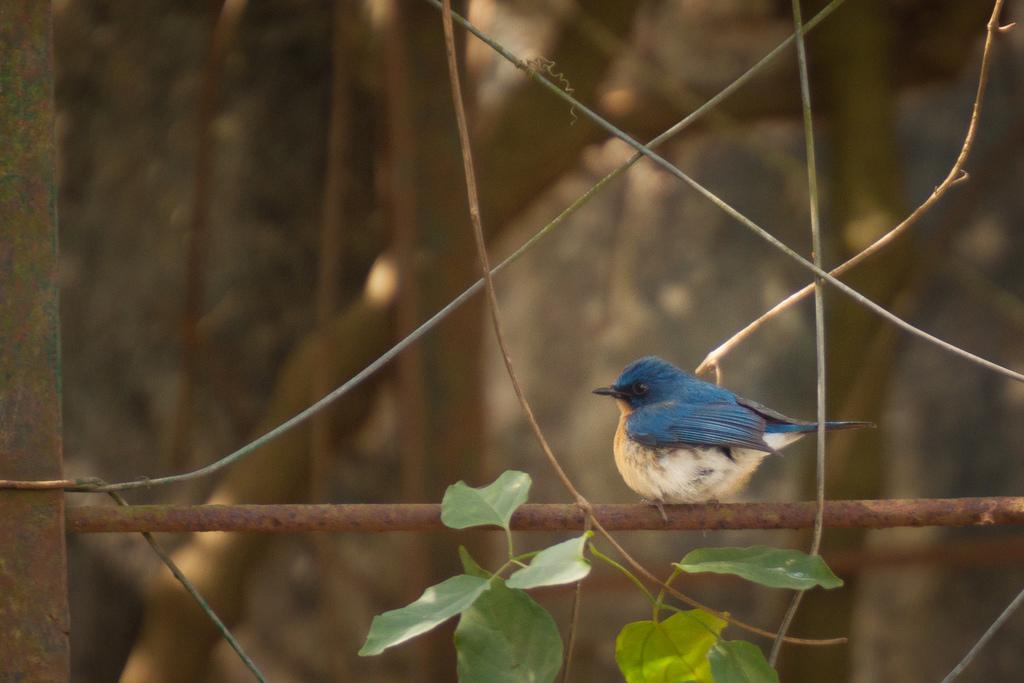What type of animal is on the road in the image? There is a bird on the road in the image. What type of vegetation can be seen in the image? Leaves and dried branches are visible in the image. How would you describe the background of the background of the image? The background of the image is blurred. What type of memory is being used in the image? There is no reference to any memory or memory-related objects in the image. 